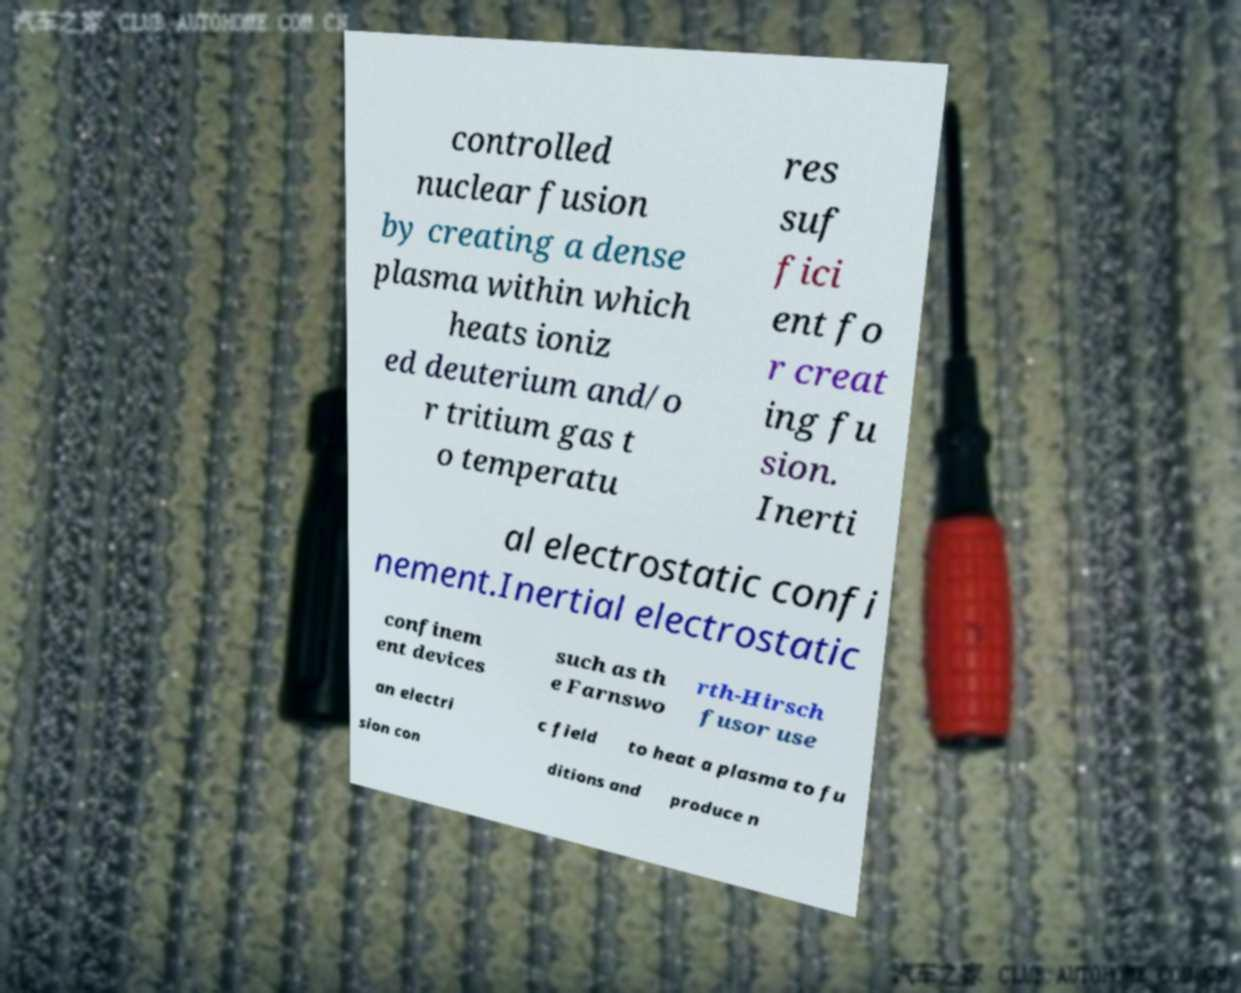For documentation purposes, I need the text within this image transcribed. Could you provide that? controlled nuclear fusion by creating a dense plasma within which heats ioniz ed deuterium and/o r tritium gas t o temperatu res suf fici ent fo r creat ing fu sion. Inerti al electrostatic confi nement.Inertial electrostatic confinem ent devices such as th e Farnswo rth-Hirsch fusor use an electri c field to heat a plasma to fu sion con ditions and produce n 